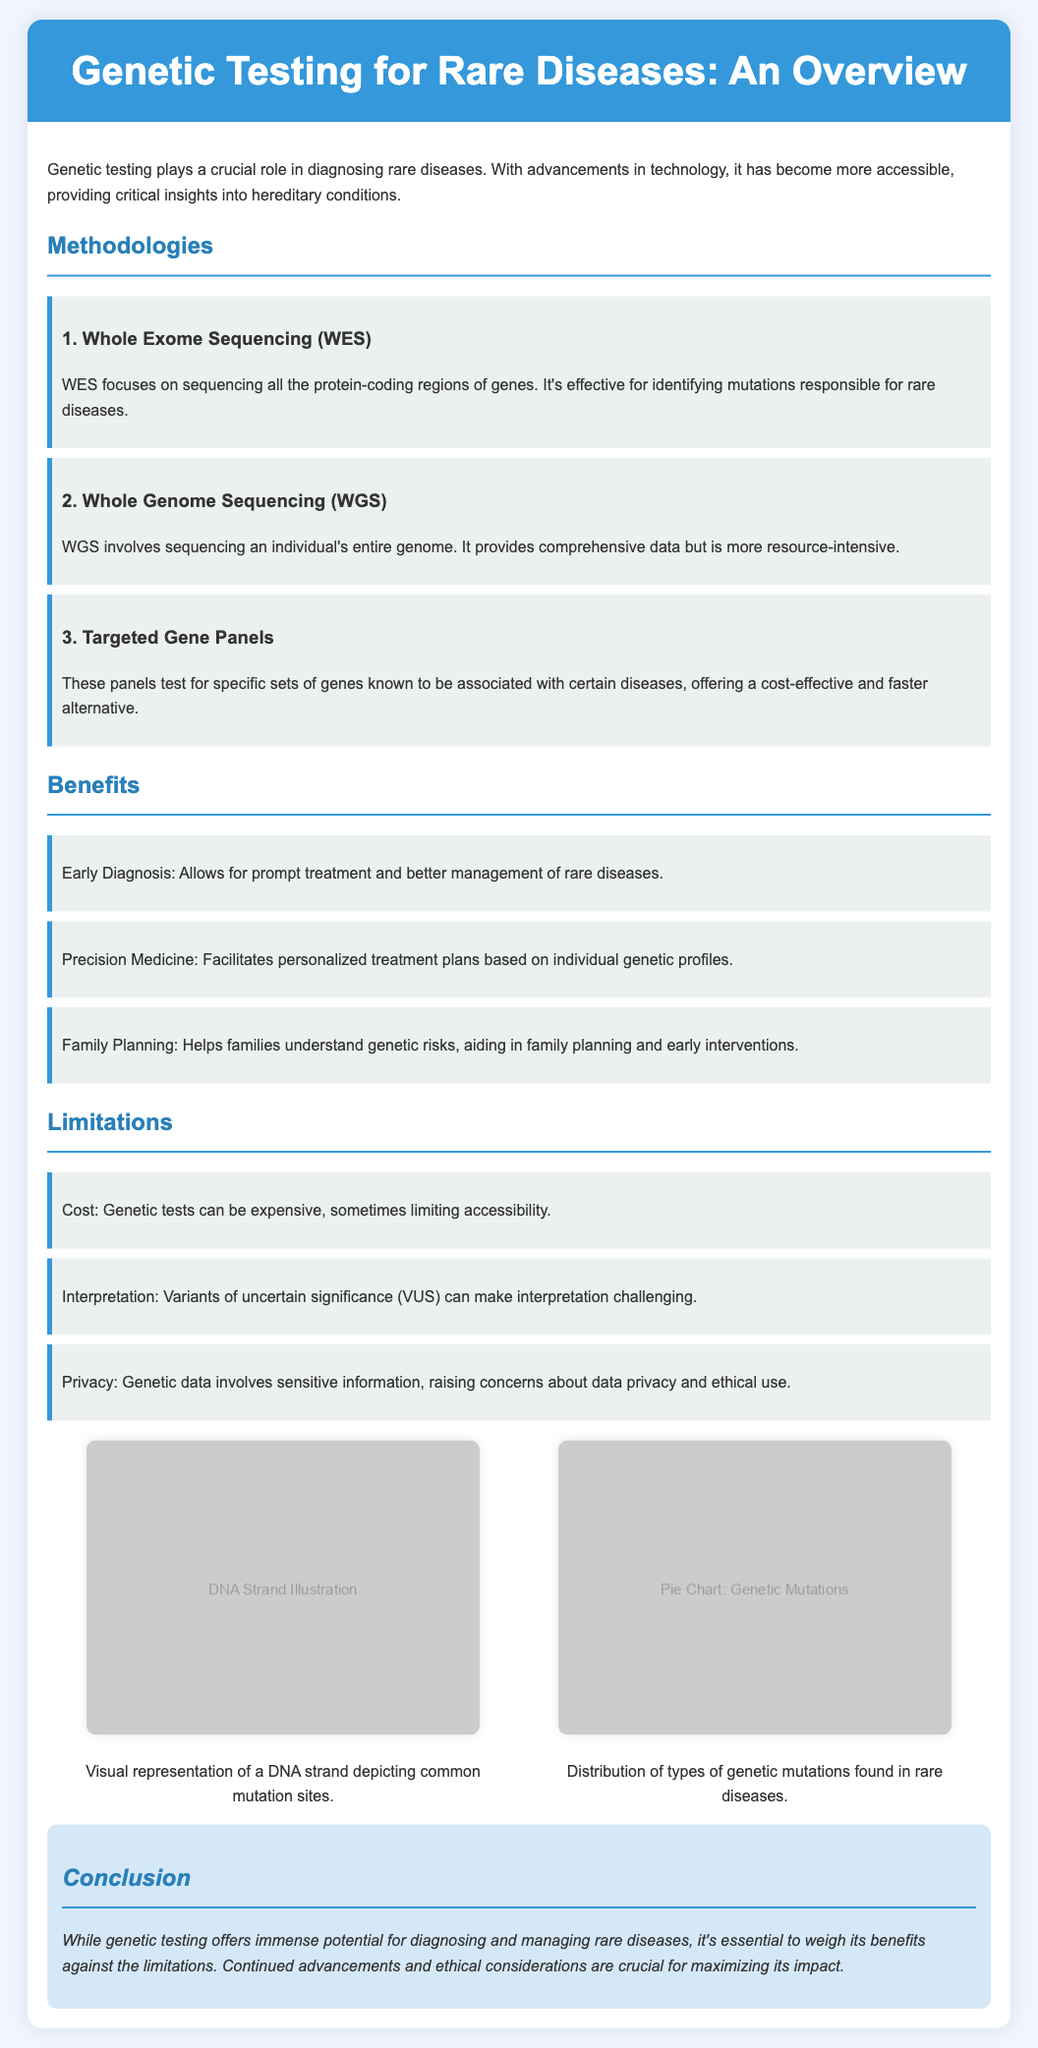What are the three methodologies for genetic testing mentioned? The document lists three methodologies: Whole Exome Sequencing, Whole Genome Sequencing, and Targeted Gene Panels.
Answer: Whole Exome Sequencing, Whole Genome Sequencing, Targeted Gene Panels What is the benefit of genetic testing that aids in family planning? The document states that genetic testing helps families understand genetic risks, aiding in family planning and early interventions.
Answer: Family Planning What are the costs associated with genetic testing described in the limitations? The document mentions that genetic tests can be expensive, sometimes limiting accessibility.
Answer: Cost How does Whole Exome Sequencing contribute to rare disease diagnosis? The document explains that WES focuses on sequencing all the protein-coding regions of genes, effective for identifying mutations responsible for rare diseases.
Answer: Identifying mutations What does the pie chart visualize? The pie chart depicts the distribution of types of genetic mutations found in rare diseases.
Answer: Genetic mutations Which limitation involves interpretation issues? The document lists that Variants of uncertain significance (VUS) can make interpretation challenging as a limitation.
Answer: Variants of uncertain significance What is the main conclusion about genetic testing? The document concludes that while genetic testing has immense potential, it is essential to weigh benefits against its limitations.
Answer: Weigh benefits against limitations What type of illustration is provided in the visual aids? The visual aid includes a DNA strand illustration that depicts common mutation sites.
Answer: DNA strand illustration 